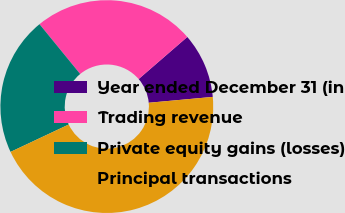<chart> <loc_0><loc_0><loc_500><loc_500><pie_chart><fcel>Year ended December 31 (in<fcel>Trading revenue<fcel>Private equity gains (losses)<fcel>Principal transactions<nl><fcel>9.9%<fcel>24.55%<fcel>21.1%<fcel>44.45%<nl></chart> 